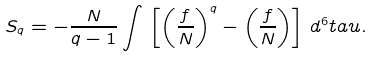Convert formula to latex. <formula><loc_0><loc_0><loc_500><loc_500>S _ { q } = - \frac { N } { q - 1 } \int \, \left [ \left ( \frac { f } { N } \right ) ^ { q } - \left ( \frac { f } { N } \right ) \right ] \, d ^ { 6 } t a u .</formula> 